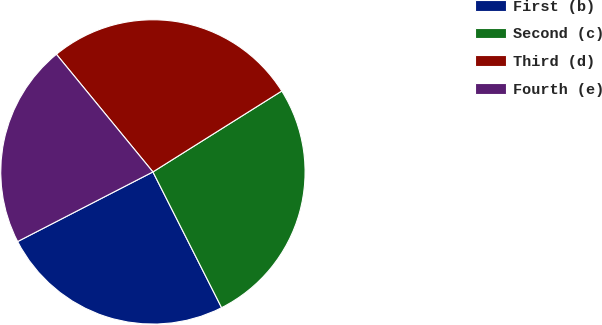<chart> <loc_0><loc_0><loc_500><loc_500><pie_chart><fcel>First (b)<fcel>Second (c)<fcel>Third (d)<fcel>Fourth (e)<nl><fcel>24.89%<fcel>26.47%<fcel>27.01%<fcel>21.63%<nl></chart> 